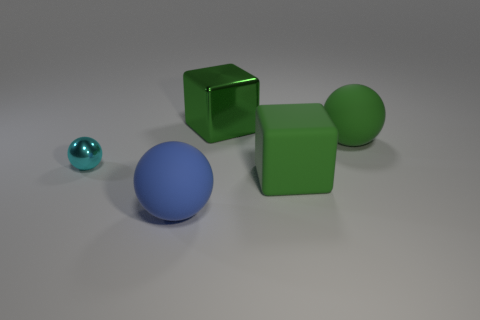Add 2 large green cubes. How many objects exist? 7 Subtract all spheres. How many objects are left? 2 Subtract 0 blue cylinders. How many objects are left? 5 Subtract all cyan spheres. Subtract all small metal objects. How many objects are left? 3 Add 4 metal objects. How many metal objects are left? 6 Add 2 tiny spheres. How many tiny spheres exist? 3 